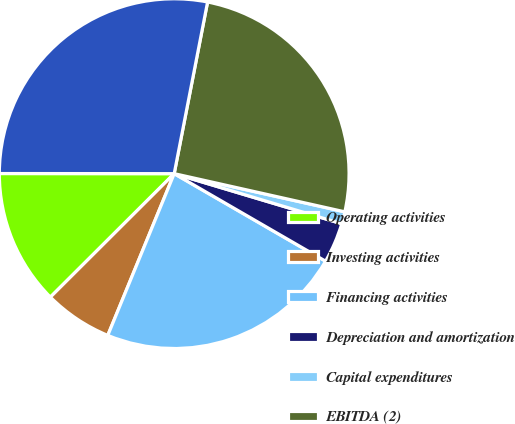<chart> <loc_0><loc_0><loc_500><loc_500><pie_chart><fcel>Operating activities<fcel>Investing activities<fcel>Financing activities<fcel>Depreciation and amortization<fcel>Capital expenditures<fcel>EBITDA (2)<fcel>EBITDA As Defined (2)<nl><fcel>12.49%<fcel>6.32%<fcel>22.86%<fcel>3.72%<fcel>1.12%<fcel>25.45%<fcel>28.05%<nl></chart> 